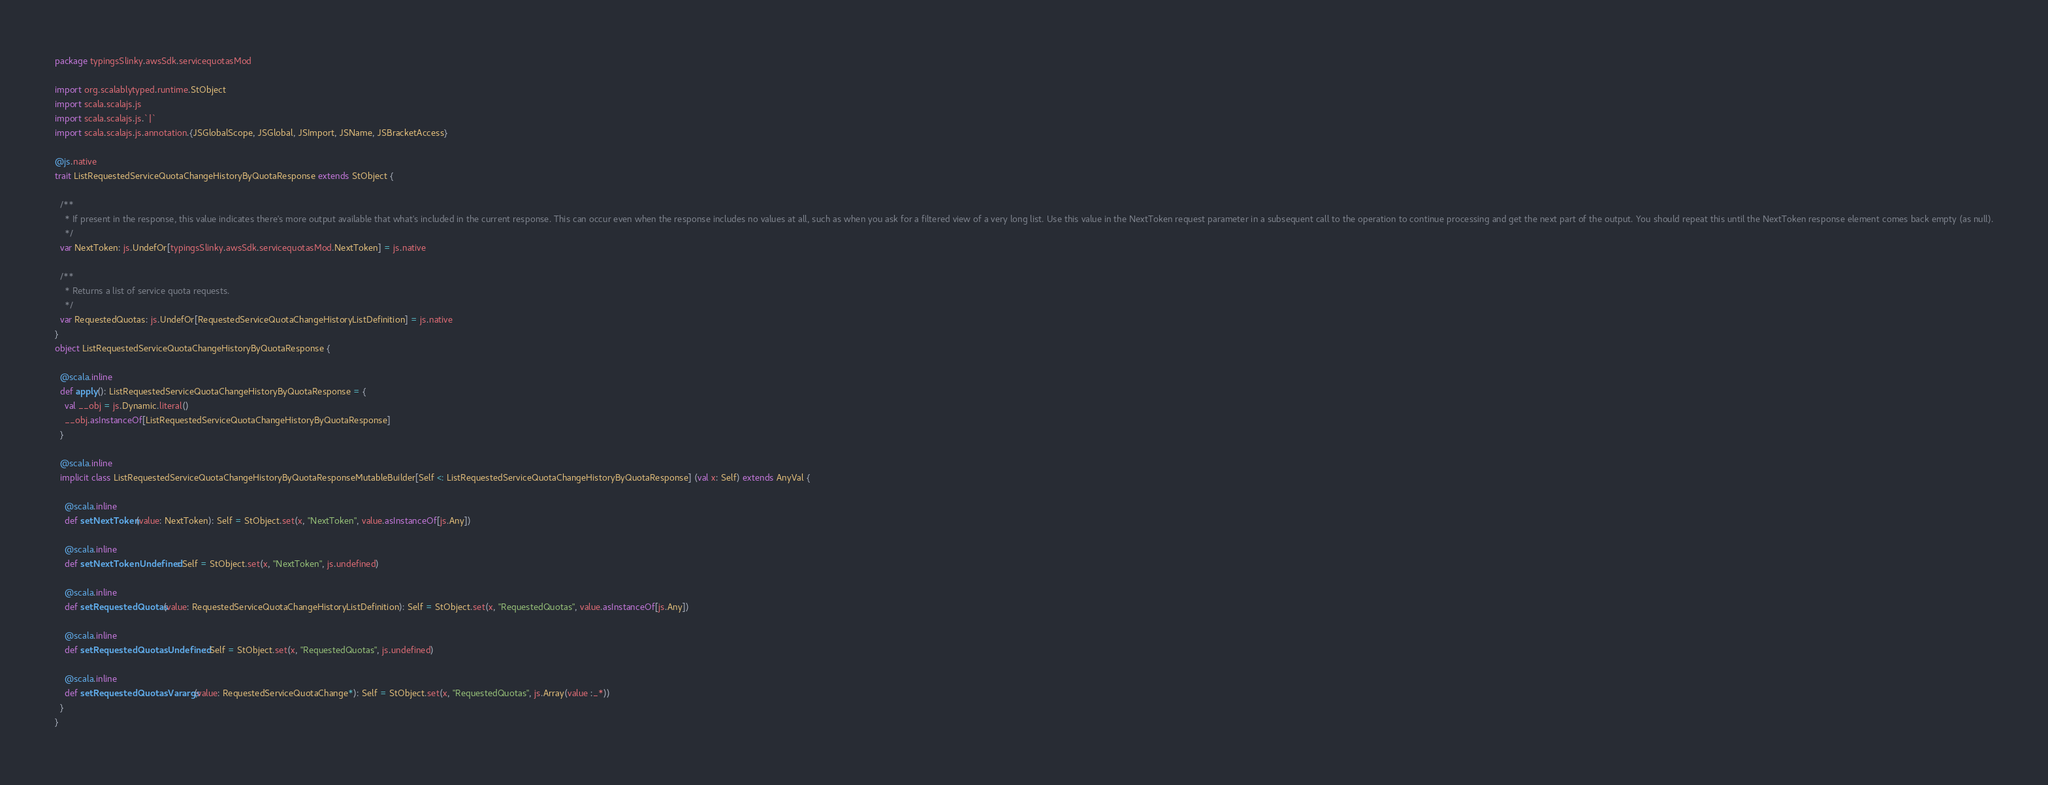Convert code to text. <code><loc_0><loc_0><loc_500><loc_500><_Scala_>package typingsSlinky.awsSdk.servicequotasMod

import org.scalablytyped.runtime.StObject
import scala.scalajs.js
import scala.scalajs.js.`|`
import scala.scalajs.js.annotation.{JSGlobalScope, JSGlobal, JSImport, JSName, JSBracketAccess}

@js.native
trait ListRequestedServiceQuotaChangeHistoryByQuotaResponse extends StObject {
  
  /**
    * If present in the response, this value indicates there's more output available that what's included in the current response. This can occur even when the response includes no values at all, such as when you ask for a filtered view of a very long list. Use this value in the NextToken request parameter in a subsequent call to the operation to continue processing and get the next part of the output. You should repeat this until the NextToken response element comes back empty (as null).
    */
  var NextToken: js.UndefOr[typingsSlinky.awsSdk.servicequotasMod.NextToken] = js.native
  
  /**
    * Returns a list of service quota requests.
    */
  var RequestedQuotas: js.UndefOr[RequestedServiceQuotaChangeHistoryListDefinition] = js.native
}
object ListRequestedServiceQuotaChangeHistoryByQuotaResponse {
  
  @scala.inline
  def apply(): ListRequestedServiceQuotaChangeHistoryByQuotaResponse = {
    val __obj = js.Dynamic.literal()
    __obj.asInstanceOf[ListRequestedServiceQuotaChangeHistoryByQuotaResponse]
  }
  
  @scala.inline
  implicit class ListRequestedServiceQuotaChangeHistoryByQuotaResponseMutableBuilder[Self <: ListRequestedServiceQuotaChangeHistoryByQuotaResponse] (val x: Self) extends AnyVal {
    
    @scala.inline
    def setNextToken(value: NextToken): Self = StObject.set(x, "NextToken", value.asInstanceOf[js.Any])
    
    @scala.inline
    def setNextTokenUndefined: Self = StObject.set(x, "NextToken", js.undefined)
    
    @scala.inline
    def setRequestedQuotas(value: RequestedServiceQuotaChangeHistoryListDefinition): Self = StObject.set(x, "RequestedQuotas", value.asInstanceOf[js.Any])
    
    @scala.inline
    def setRequestedQuotasUndefined: Self = StObject.set(x, "RequestedQuotas", js.undefined)
    
    @scala.inline
    def setRequestedQuotasVarargs(value: RequestedServiceQuotaChange*): Self = StObject.set(x, "RequestedQuotas", js.Array(value :_*))
  }
}
</code> 